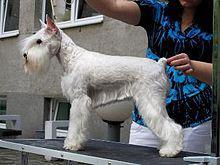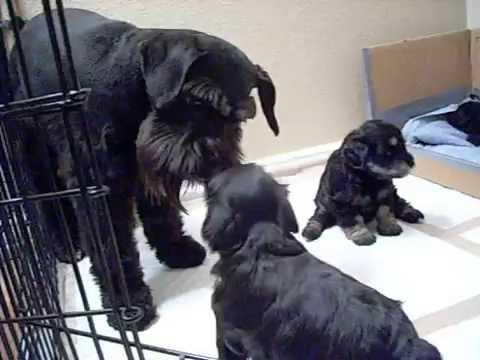The first image is the image on the left, the second image is the image on the right. For the images displayed, is the sentence "One image shows a groomed schnauzer standing on an elevated black surface facing leftward." factually correct? Answer yes or no. Yes. The first image is the image on the left, the second image is the image on the right. Analyze the images presented: Is the assertion "A single dog is standing and facing left in one of the images." valid? Answer yes or no. Yes. 